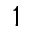Convert formula to latex. <formula><loc_0><loc_0><loc_500><loc_500>1</formula> 